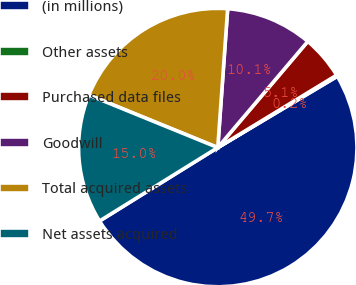Convert chart to OTSL. <chart><loc_0><loc_0><loc_500><loc_500><pie_chart><fcel>(in millions)<fcel>Other assets<fcel>Purchased data files<fcel>Goodwill<fcel>Total acquired assets<fcel>Net assets acquired<nl><fcel>49.71%<fcel>0.15%<fcel>5.1%<fcel>10.06%<fcel>19.97%<fcel>15.01%<nl></chart> 